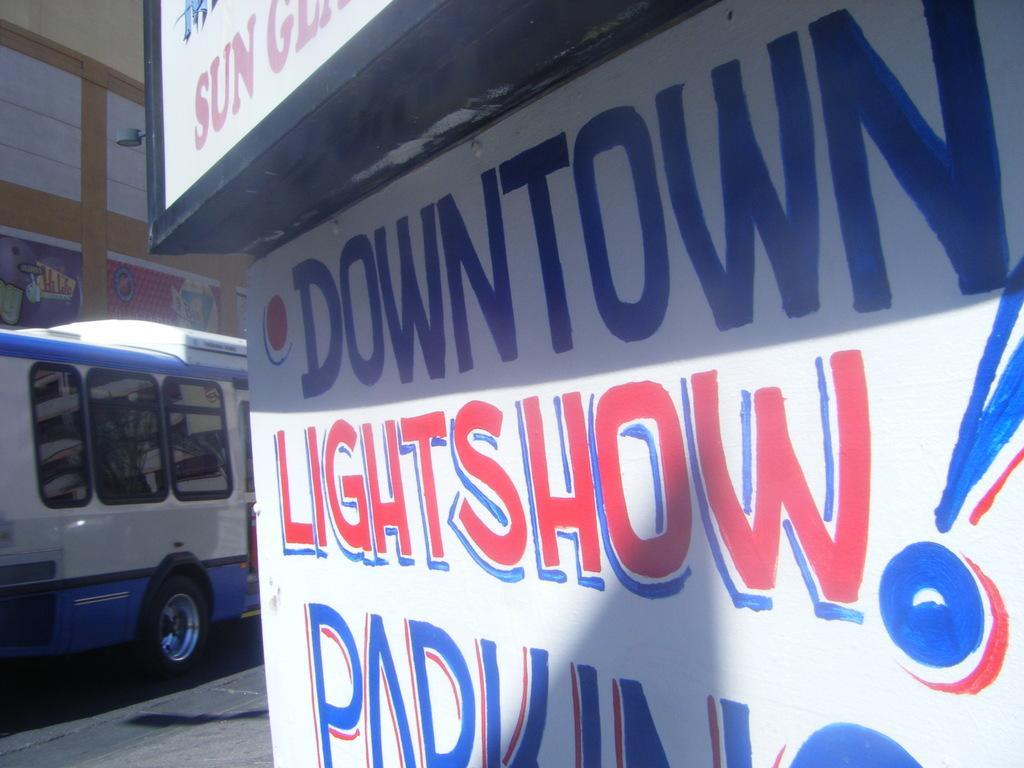Describe this image in one or two sentences. In the picture we can see a bus on the road which is blue and white in color with windows and glasses and beside it, we can see a building wall with some posters on it and in the opposite direction we can see a white color board on it we can see it is written as downtown light show parking and some board on top of it. 